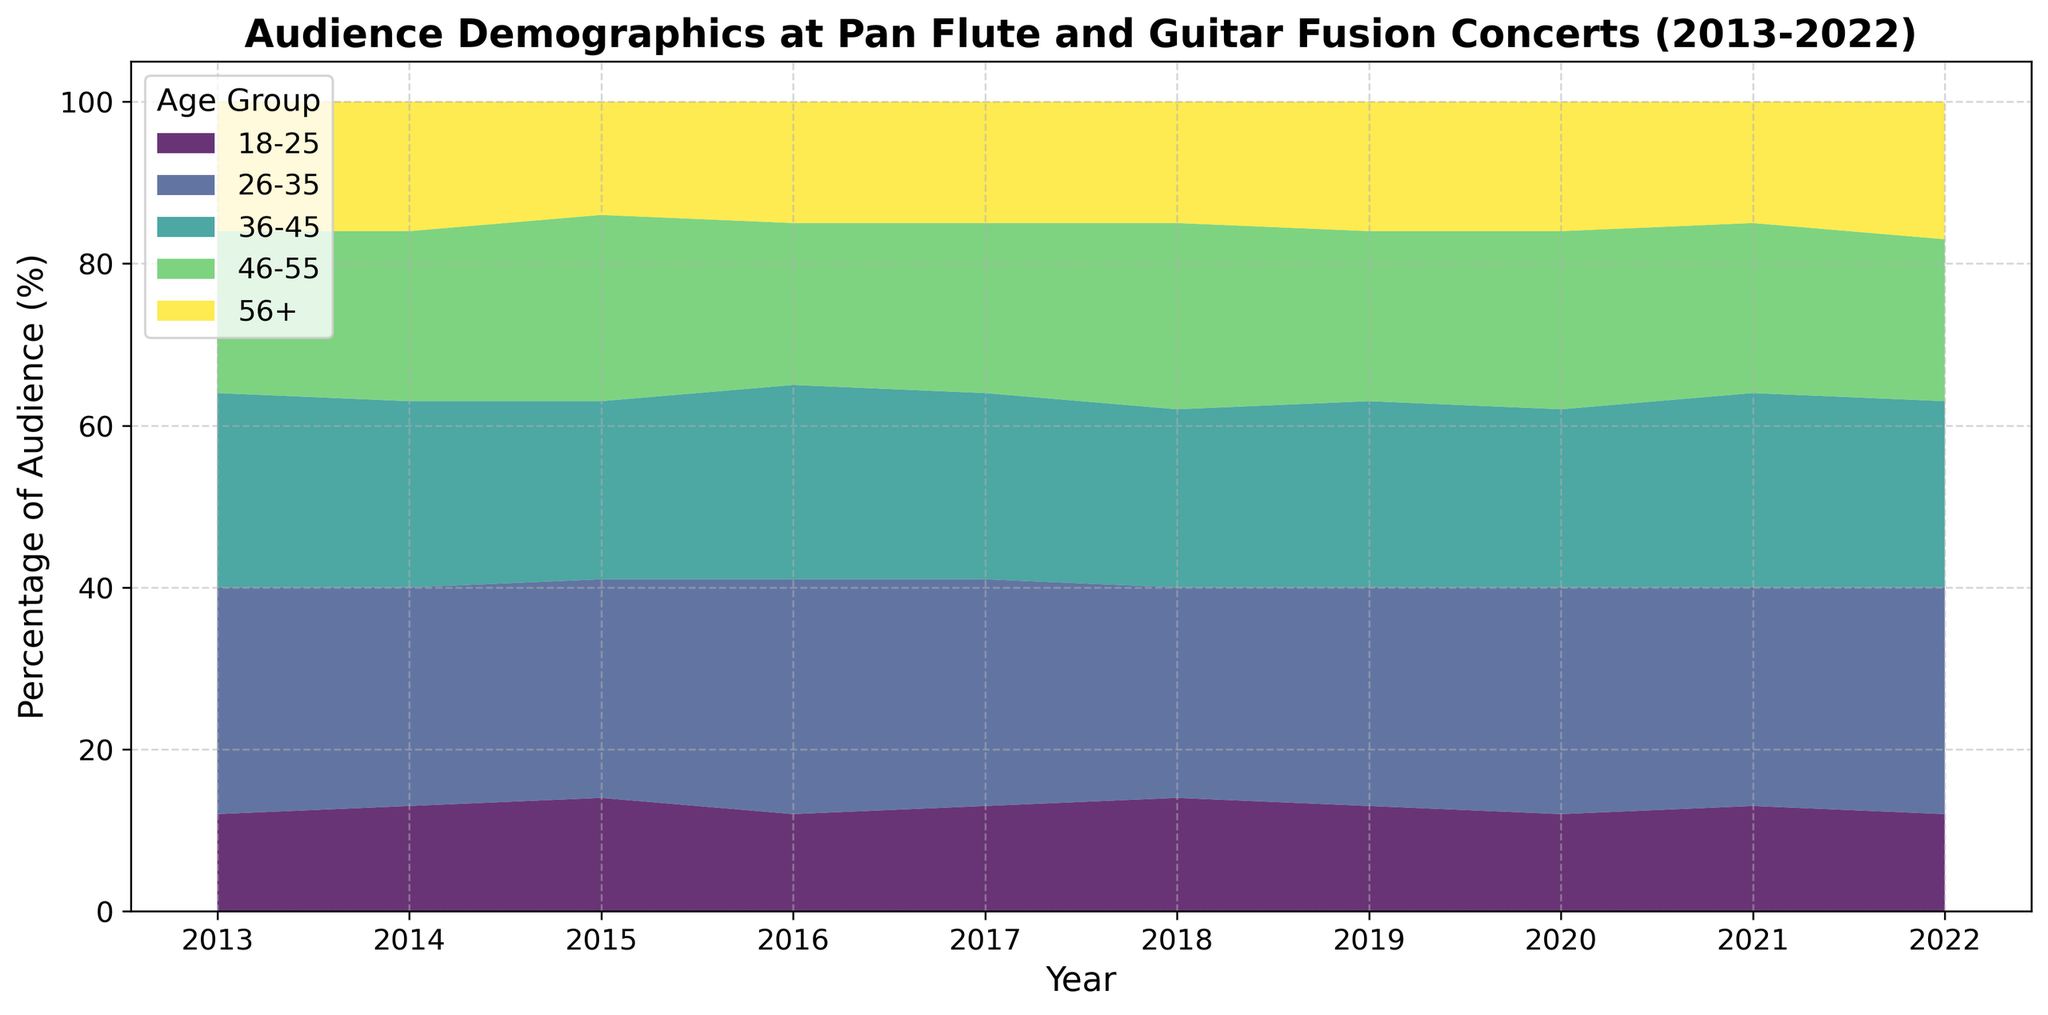what trend can be observed in the 26-35 age group's audience percentage over the years? Observing the area chart over the years, the 26-35 age group generally maintains a majority presence among the audience. Starting from around 28% in 2013, it fluctuates slightly but remains within the range of 26-29% until 2022, indicating a stable demographic for this age group.
Answer: Stability with minor fluctuations between 2013 and 2022, which age group saw the largest increase in audience percentage? To determine the largest increase, compare the percentage values from 2013 to 2022 for all age groups. The age group 56+ increases from 16% in 2013 to 17% in 2022, showing a net gain of 1%. The rest of the age groups show less change.
Answer: 56+ in which year did the 36-45 age group have the highest representation? By examining the heights of the colored segments representing the 36-45 age group in each year, the peak seems to be at 24% in both 2016 and 2021.
Answer: 2016 and 2021 which age group consistently has the lowest percentage of the audience? Scan the area chart for the age groups represented, and observe the relative heights. The 18-25 age group consistently appears the smallest across all years, often around 12-14%.
Answer: 18-25 how did the percentage of the 46-55 age group change from 2020 to 2022? From the chart, in 2020, the 46-55 age group is at 22%. By 2022, it decreases to 20%. Therefore, the change can be calculated as 22% - 20% = 2%.
Answer: Decrease by 2% which age group showed a decline in audience percentage in 2015 compared to 2014? By comparing the visual peaks of 2014 and 2015, the 36-45 age group shows a decline from 23% to 22%.
Answer: 36-45 what is the total combined audience percentage of the 26-35 and 36-45 age groups in 2018? The chart indicates 26% for the 26-35 age group and 22% for the 36-45 age group in 2018. Adding them together results in 26% + 22% = 48%.
Answer: 48% which age group experienced the most stability in their audience percentage from 2013 to 2022? By inspecting the areas, the 26-35 age group shows the least fluctuation, consistently around 26-29% over the years.
Answer: 26-35 